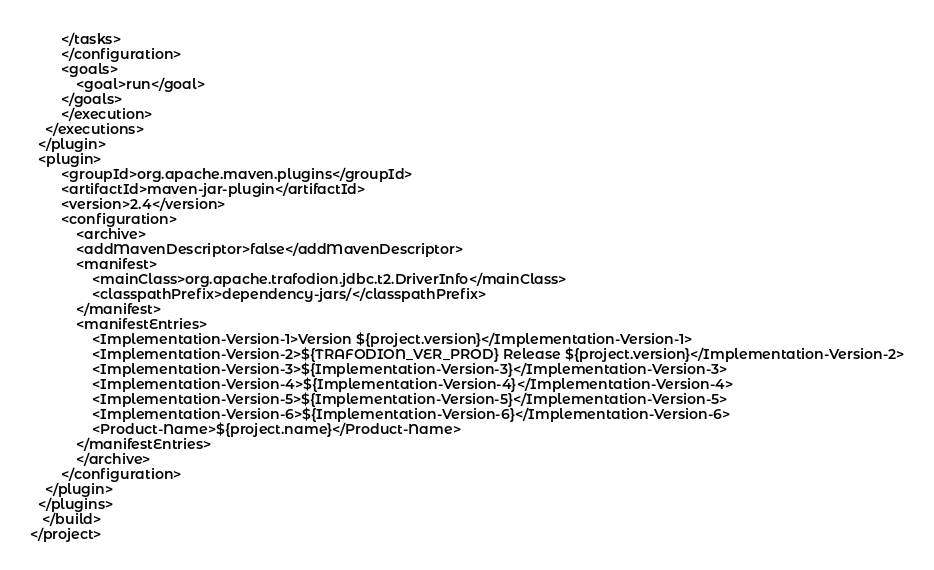Convert code to text. <code><loc_0><loc_0><loc_500><loc_500><_XML_>        </tasks>
        </configuration>
        <goals>
            <goal>run</goal>
        </goals>
        </execution>
    </executions>
  </plugin>
  <plugin>
        <groupId>org.apache.maven.plugins</groupId>
        <artifactId>maven-jar-plugin</artifactId>
        <version>2.4</version>
        <configuration>
            <archive>
            <addMavenDescriptor>false</addMavenDescriptor>
            <manifest>
                <mainClass>org.apache.trafodion.jdbc.t2.DriverInfo</mainClass>
                <classpathPrefix>dependency-jars/</classpathPrefix>
            </manifest>
            <manifestEntries>
                <Implementation-Version-1>Version ${project.version}</Implementation-Version-1> 
                <Implementation-Version-2>${TRAFODION_VER_PROD} Release ${project.version}</Implementation-Version-2>
                <Implementation-Version-3>${Implementation-Version-3}</Implementation-Version-3>
                <Implementation-Version-4>${Implementation-Version-4}</Implementation-Version-4>
                <Implementation-Version-5>${Implementation-Version-5}</Implementation-Version-5>
                <Implementation-Version-6>${Implementation-Version-6}</Implementation-Version-6>
                <Product-Name>${project.name}</Product-Name>
            </manifestEntries>
            </archive>
        </configuration>
    </plugin>
  </plugins>
   </build>
</project>
</code> 